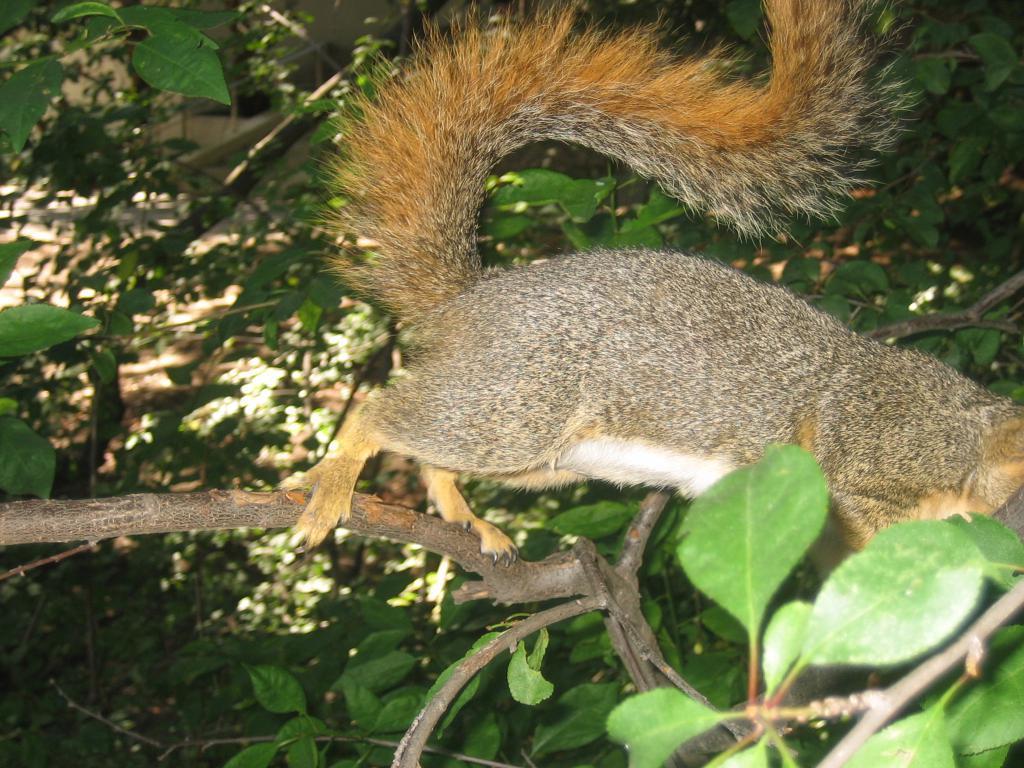Could you give a brief overview of what you see in this image? In this image we can see an animal on the branch of the tree, also we can see some plants, and trees. 